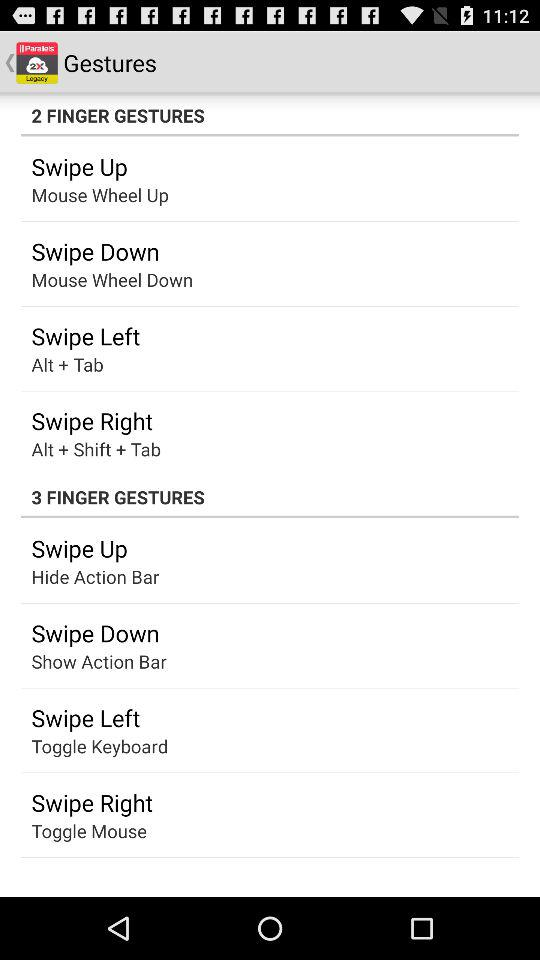How many gestures are there for 2 fingers?
Answer the question using a single word or phrase. 4 